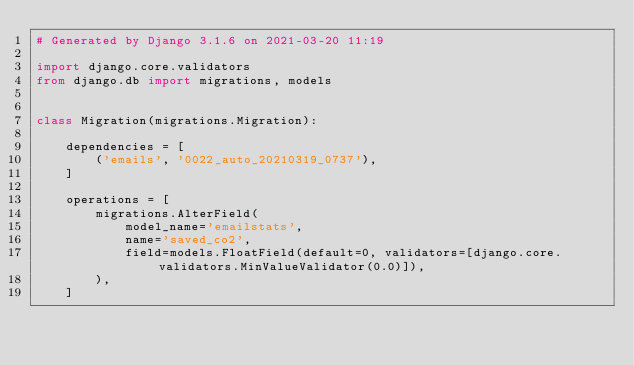<code> <loc_0><loc_0><loc_500><loc_500><_Python_># Generated by Django 3.1.6 on 2021-03-20 11:19

import django.core.validators
from django.db import migrations, models


class Migration(migrations.Migration):

    dependencies = [
        ('emails', '0022_auto_20210319_0737'),
    ]

    operations = [
        migrations.AlterField(
            model_name='emailstats',
            name='saved_co2',
            field=models.FloatField(default=0, validators=[django.core.validators.MinValueValidator(0.0)]),
        ),
    ]
</code> 